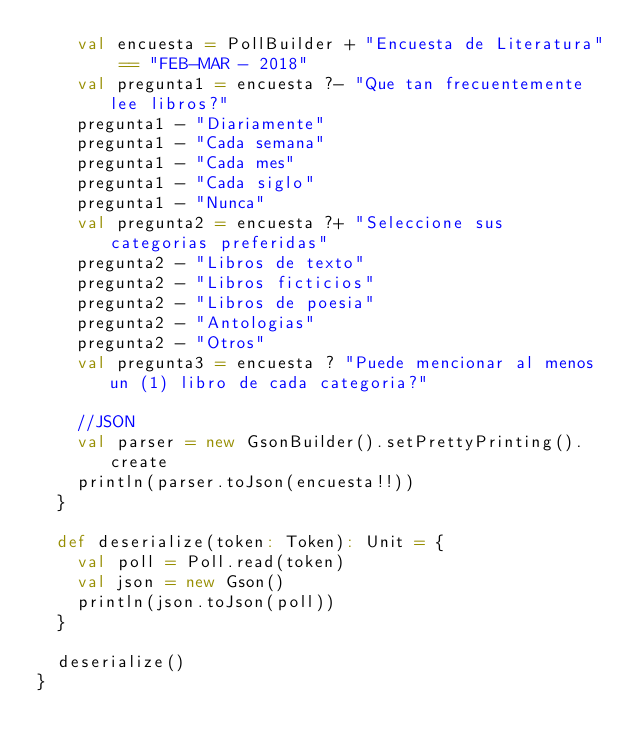<code> <loc_0><loc_0><loc_500><loc_500><_Scala_>    val encuesta = PollBuilder + "Encuesta de Literatura" == "FEB-MAR - 2018"
    val pregunta1 = encuesta ?- "Que tan frecuentemente lee libros?"
    pregunta1 - "Diariamente"
    pregunta1 - "Cada semana"
    pregunta1 - "Cada mes"
    pregunta1 - "Cada siglo"
    pregunta1 - "Nunca"
    val pregunta2 = encuesta ?+ "Seleccione sus categorias preferidas"
    pregunta2 - "Libros de texto"
    pregunta2 - "Libros ficticios"
    pregunta2 - "Libros de poesia"
    pregunta2 - "Antologias"
    pregunta2 - "Otros"
    val pregunta3 = encuesta ? "Puede mencionar al menos un (1) libro de cada categoria?"

    //JSON
    val parser = new GsonBuilder().setPrettyPrinting().create
    println(parser.toJson(encuesta!!))
  }

  def deserialize(token: Token): Unit = {
    val poll = Poll.read(token)
    val json = new Gson()
    println(json.toJson(poll))
  }

  deserialize()
}
</code> 